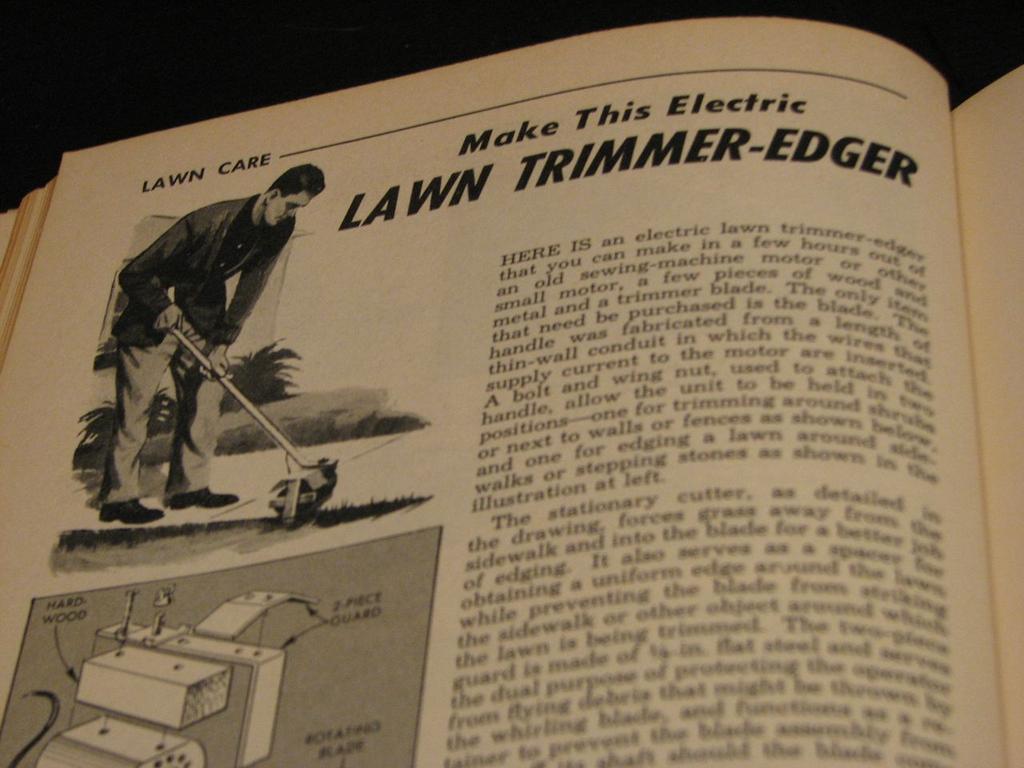What chapter is this?
Offer a terse response. Lawn care. 